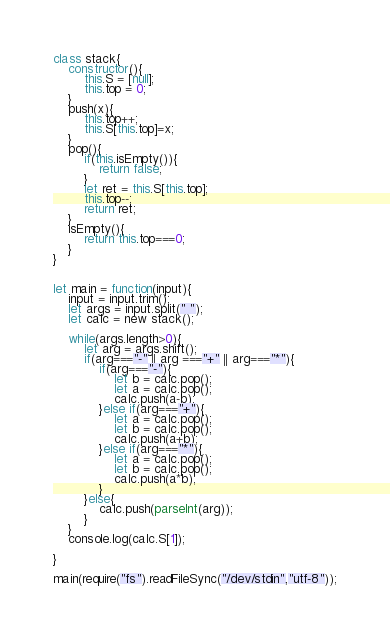Convert code to text. <code><loc_0><loc_0><loc_500><loc_500><_JavaScript_>class stack{
    constructor(){
        this.S = [null];
        this.top = 0;
    }
    push(x){
        this.top++;
        this.S[this.top]=x;
    }
    pop(){
        if(this.isEmpty()){
            return false;
        }
        let ret = this.S[this.top];
        this.top--;
        return ret;
    }
    isEmpty(){
        return this.top===0;
    }
}


let main = function(input){
    input = input.trim();
    let args = input.split(" ");
    let calc = new stack();
    
    while(args.length>0){
        let arg = args.shift();
        if(arg==="-" || arg ==="+" || arg==="*"){
            if(arg==="-"){
                let b = calc.pop();
                let a = calc.pop();
                calc.push(a-b);
            }else if(arg==="+"){
                let a = calc.pop();
                let b = calc.pop();
                calc.push(a+b);
            }else if(arg==="*"){
                let a = calc.pop();
                let b = calc.pop();
                calc.push(a*b);
            }
        }else{
            calc.push(parseInt(arg));
        }
    }
    console.log(calc.S[1]);
    
}

main(require("fs").readFileSync("/dev/stdin","utf-8"));

</code> 